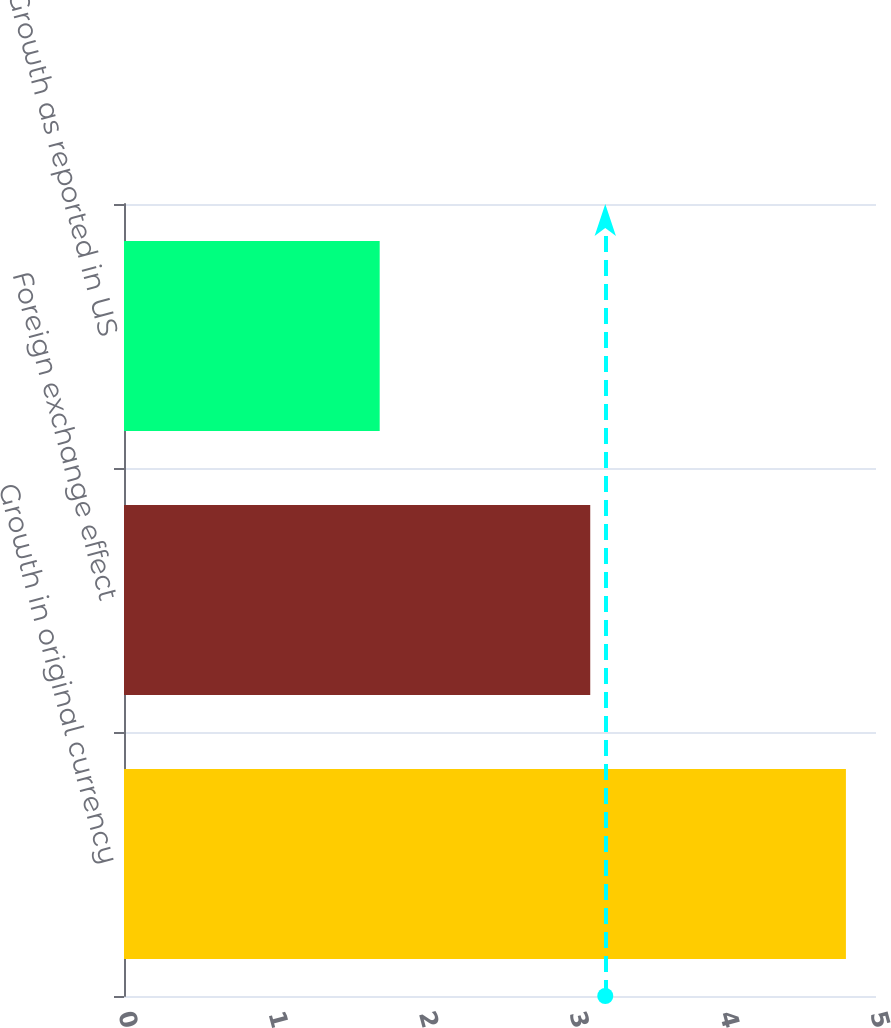Convert chart to OTSL. <chart><loc_0><loc_0><loc_500><loc_500><bar_chart><fcel>Growth in original currency<fcel>Foreign exchange effect<fcel>Growth as reported in US<nl><fcel>4.8<fcel>3.1<fcel>1.7<nl></chart> 